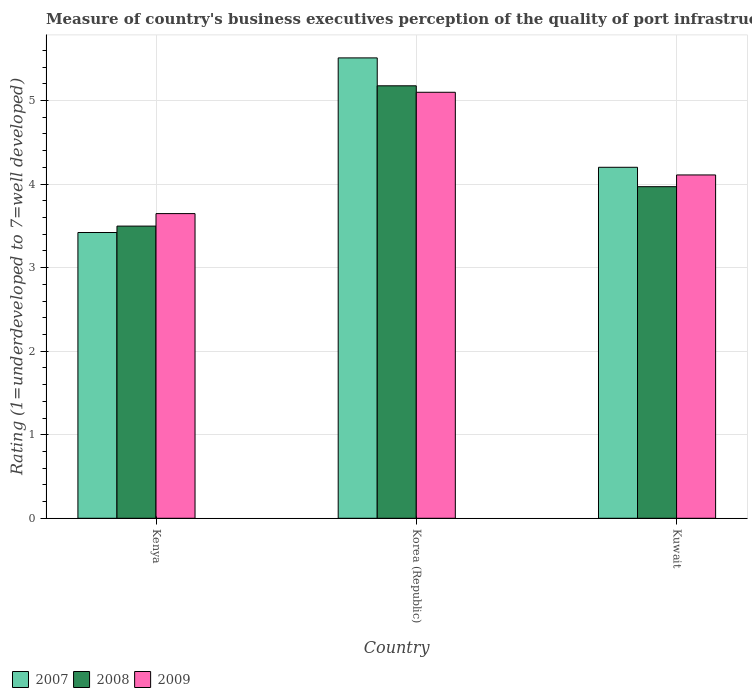How many groups of bars are there?
Offer a very short reply. 3. Are the number of bars per tick equal to the number of legend labels?
Ensure brevity in your answer.  Yes. How many bars are there on the 3rd tick from the left?
Give a very brief answer. 3. What is the label of the 1st group of bars from the left?
Provide a short and direct response. Kenya. In how many cases, is the number of bars for a given country not equal to the number of legend labels?
Your response must be concise. 0. What is the ratings of the quality of port infrastructure in 2008 in Kenya?
Give a very brief answer. 3.5. Across all countries, what is the maximum ratings of the quality of port infrastructure in 2008?
Your answer should be compact. 5.18. Across all countries, what is the minimum ratings of the quality of port infrastructure in 2007?
Make the answer very short. 3.42. In which country was the ratings of the quality of port infrastructure in 2007 maximum?
Offer a very short reply. Korea (Republic). In which country was the ratings of the quality of port infrastructure in 2007 minimum?
Give a very brief answer. Kenya. What is the total ratings of the quality of port infrastructure in 2009 in the graph?
Keep it short and to the point. 12.85. What is the difference between the ratings of the quality of port infrastructure in 2009 in Kenya and that in Korea (Republic)?
Keep it short and to the point. -1.45. What is the difference between the ratings of the quality of port infrastructure in 2007 in Korea (Republic) and the ratings of the quality of port infrastructure in 2009 in Kenya?
Provide a succinct answer. 1.86. What is the average ratings of the quality of port infrastructure in 2007 per country?
Offer a terse response. 4.38. What is the difference between the ratings of the quality of port infrastructure of/in 2009 and ratings of the quality of port infrastructure of/in 2007 in Korea (Republic)?
Your answer should be compact. -0.41. What is the ratio of the ratings of the quality of port infrastructure in 2007 in Kenya to that in Kuwait?
Your answer should be very brief. 0.81. Is the ratings of the quality of port infrastructure in 2009 in Korea (Republic) less than that in Kuwait?
Your answer should be very brief. No. Is the difference between the ratings of the quality of port infrastructure in 2009 in Korea (Republic) and Kuwait greater than the difference between the ratings of the quality of port infrastructure in 2007 in Korea (Republic) and Kuwait?
Ensure brevity in your answer.  No. What is the difference between the highest and the second highest ratings of the quality of port infrastructure in 2007?
Offer a terse response. -0.78. What is the difference between the highest and the lowest ratings of the quality of port infrastructure in 2008?
Offer a terse response. 1.68. In how many countries, is the ratings of the quality of port infrastructure in 2009 greater than the average ratings of the quality of port infrastructure in 2009 taken over all countries?
Your answer should be compact. 1. What does the 3rd bar from the left in Kenya represents?
Offer a very short reply. 2009. What does the 1st bar from the right in Kuwait represents?
Offer a very short reply. 2009. How many bars are there?
Make the answer very short. 9. Does the graph contain any zero values?
Your answer should be very brief. No. Does the graph contain grids?
Keep it short and to the point. Yes. Where does the legend appear in the graph?
Offer a very short reply. Bottom left. How many legend labels are there?
Offer a very short reply. 3. What is the title of the graph?
Provide a short and direct response. Measure of country's business executives perception of the quality of port infrastructure. Does "2008" appear as one of the legend labels in the graph?
Keep it short and to the point. Yes. What is the label or title of the Y-axis?
Your answer should be compact. Rating (1=underdeveloped to 7=well developed). What is the Rating (1=underdeveloped to 7=well developed) in 2007 in Kenya?
Provide a succinct answer. 3.42. What is the Rating (1=underdeveloped to 7=well developed) in 2008 in Kenya?
Offer a very short reply. 3.5. What is the Rating (1=underdeveloped to 7=well developed) of 2009 in Kenya?
Offer a very short reply. 3.65. What is the Rating (1=underdeveloped to 7=well developed) in 2007 in Korea (Republic)?
Make the answer very short. 5.51. What is the Rating (1=underdeveloped to 7=well developed) of 2008 in Korea (Republic)?
Provide a succinct answer. 5.18. What is the Rating (1=underdeveloped to 7=well developed) in 2009 in Korea (Republic)?
Offer a terse response. 5.1. What is the Rating (1=underdeveloped to 7=well developed) in 2007 in Kuwait?
Provide a succinct answer. 4.2. What is the Rating (1=underdeveloped to 7=well developed) of 2008 in Kuwait?
Your answer should be compact. 3.97. What is the Rating (1=underdeveloped to 7=well developed) in 2009 in Kuwait?
Your answer should be very brief. 4.11. Across all countries, what is the maximum Rating (1=underdeveloped to 7=well developed) in 2007?
Keep it short and to the point. 5.51. Across all countries, what is the maximum Rating (1=underdeveloped to 7=well developed) in 2008?
Ensure brevity in your answer.  5.18. Across all countries, what is the maximum Rating (1=underdeveloped to 7=well developed) of 2009?
Provide a short and direct response. 5.1. Across all countries, what is the minimum Rating (1=underdeveloped to 7=well developed) in 2007?
Make the answer very short. 3.42. Across all countries, what is the minimum Rating (1=underdeveloped to 7=well developed) in 2008?
Your answer should be very brief. 3.5. Across all countries, what is the minimum Rating (1=underdeveloped to 7=well developed) of 2009?
Provide a succinct answer. 3.65. What is the total Rating (1=underdeveloped to 7=well developed) in 2007 in the graph?
Ensure brevity in your answer.  13.13. What is the total Rating (1=underdeveloped to 7=well developed) in 2008 in the graph?
Ensure brevity in your answer.  12.64. What is the total Rating (1=underdeveloped to 7=well developed) in 2009 in the graph?
Ensure brevity in your answer.  12.85. What is the difference between the Rating (1=underdeveloped to 7=well developed) in 2007 in Kenya and that in Korea (Republic)?
Make the answer very short. -2.09. What is the difference between the Rating (1=underdeveloped to 7=well developed) of 2008 in Kenya and that in Korea (Republic)?
Provide a short and direct response. -1.68. What is the difference between the Rating (1=underdeveloped to 7=well developed) of 2009 in Kenya and that in Korea (Republic)?
Offer a very short reply. -1.45. What is the difference between the Rating (1=underdeveloped to 7=well developed) of 2007 in Kenya and that in Kuwait?
Keep it short and to the point. -0.78. What is the difference between the Rating (1=underdeveloped to 7=well developed) in 2008 in Kenya and that in Kuwait?
Give a very brief answer. -0.47. What is the difference between the Rating (1=underdeveloped to 7=well developed) of 2009 in Kenya and that in Kuwait?
Make the answer very short. -0.46. What is the difference between the Rating (1=underdeveloped to 7=well developed) of 2007 in Korea (Republic) and that in Kuwait?
Offer a very short reply. 1.31. What is the difference between the Rating (1=underdeveloped to 7=well developed) of 2008 in Korea (Republic) and that in Kuwait?
Offer a terse response. 1.21. What is the difference between the Rating (1=underdeveloped to 7=well developed) of 2007 in Kenya and the Rating (1=underdeveloped to 7=well developed) of 2008 in Korea (Republic)?
Keep it short and to the point. -1.76. What is the difference between the Rating (1=underdeveloped to 7=well developed) in 2007 in Kenya and the Rating (1=underdeveloped to 7=well developed) in 2009 in Korea (Republic)?
Keep it short and to the point. -1.68. What is the difference between the Rating (1=underdeveloped to 7=well developed) in 2008 in Kenya and the Rating (1=underdeveloped to 7=well developed) in 2009 in Korea (Republic)?
Offer a terse response. -1.6. What is the difference between the Rating (1=underdeveloped to 7=well developed) in 2007 in Kenya and the Rating (1=underdeveloped to 7=well developed) in 2008 in Kuwait?
Offer a terse response. -0.55. What is the difference between the Rating (1=underdeveloped to 7=well developed) of 2007 in Kenya and the Rating (1=underdeveloped to 7=well developed) of 2009 in Kuwait?
Make the answer very short. -0.69. What is the difference between the Rating (1=underdeveloped to 7=well developed) of 2008 in Kenya and the Rating (1=underdeveloped to 7=well developed) of 2009 in Kuwait?
Give a very brief answer. -0.61. What is the difference between the Rating (1=underdeveloped to 7=well developed) of 2007 in Korea (Republic) and the Rating (1=underdeveloped to 7=well developed) of 2008 in Kuwait?
Your answer should be very brief. 1.54. What is the difference between the Rating (1=underdeveloped to 7=well developed) in 2007 in Korea (Republic) and the Rating (1=underdeveloped to 7=well developed) in 2009 in Kuwait?
Your answer should be compact. 1.4. What is the difference between the Rating (1=underdeveloped to 7=well developed) of 2008 in Korea (Republic) and the Rating (1=underdeveloped to 7=well developed) of 2009 in Kuwait?
Offer a very short reply. 1.07. What is the average Rating (1=underdeveloped to 7=well developed) of 2007 per country?
Make the answer very short. 4.38. What is the average Rating (1=underdeveloped to 7=well developed) in 2008 per country?
Give a very brief answer. 4.21. What is the average Rating (1=underdeveloped to 7=well developed) in 2009 per country?
Offer a very short reply. 4.28. What is the difference between the Rating (1=underdeveloped to 7=well developed) in 2007 and Rating (1=underdeveloped to 7=well developed) in 2008 in Kenya?
Provide a short and direct response. -0.08. What is the difference between the Rating (1=underdeveloped to 7=well developed) of 2007 and Rating (1=underdeveloped to 7=well developed) of 2009 in Kenya?
Your answer should be compact. -0.23. What is the difference between the Rating (1=underdeveloped to 7=well developed) in 2008 and Rating (1=underdeveloped to 7=well developed) in 2009 in Kenya?
Offer a terse response. -0.15. What is the difference between the Rating (1=underdeveloped to 7=well developed) in 2007 and Rating (1=underdeveloped to 7=well developed) in 2008 in Korea (Republic)?
Provide a short and direct response. 0.33. What is the difference between the Rating (1=underdeveloped to 7=well developed) of 2007 and Rating (1=underdeveloped to 7=well developed) of 2009 in Korea (Republic)?
Give a very brief answer. 0.41. What is the difference between the Rating (1=underdeveloped to 7=well developed) in 2008 and Rating (1=underdeveloped to 7=well developed) in 2009 in Korea (Republic)?
Provide a short and direct response. 0.08. What is the difference between the Rating (1=underdeveloped to 7=well developed) of 2007 and Rating (1=underdeveloped to 7=well developed) of 2008 in Kuwait?
Your response must be concise. 0.23. What is the difference between the Rating (1=underdeveloped to 7=well developed) of 2007 and Rating (1=underdeveloped to 7=well developed) of 2009 in Kuwait?
Your response must be concise. 0.09. What is the difference between the Rating (1=underdeveloped to 7=well developed) in 2008 and Rating (1=underdeveloped to 7=well developed) in 2009 in Kuwait?
Give a very brief answer. -0.14. What is the ratio of the Rating (1=underdeveloped to 7=well developed) of 2007 in Kenya to that in Korea (Republic)?
Provide a short and direct response. 0.62. What is the ratio of the Rating (1=underdeveloped to 7=well developed) of 2008 in Kenya to that in Korea (Republic)?
Give a very brief answer. 0.68. What is the ratio of the Rating (1=underdeveloped to 7=well developed) in 2009 in Kenya to that in Korea (Republic)?
Give a very brief answer. 0.72. What is the ratio of the Rating (1=underdeveloped to 7=well developed) of 2007 in Kenya to that in Kuwait?
Your answer should be compact. 0.81. What is the ratio of the Rating (1=underdeveloped to 7=well developed) in 2008 in Kenya to that in Kuwait?
Give a very brief answer. 0.88. What is the ratio of the Rating (1=underdeveloped to 7=well developed) in 2009 in Kenya to that in Kuwait?
Make the answer very short. 0.89. What is the ratio of the Rating (1=underdeveloped to 7=well developed) in 2007 in Korea (Republic) to that in Kuwait?
Your response must be concise. 1.31. What is the ratio of the Rating (1=underdeveloped to 7=well developed) in 2008 in Korea (Republic) to that in Kuwait?
Ensure brevity in your answer.  1.3. What is the ratio of the Rating (1=underdeveloped to 7=well developed) of 2009 in Korea (Republic) to that in Kuwait?
Your response must be concise. 1.24. What is the difference between the highest and the second highest Rating (1=underdeveloped to 7=well developed) of 2007?
Make the answer very short. 1.31. What is the difference between the highest and the second highest Rating (1=underdeveloped to 7=well developed) of 2008?
Give a very brief answer. 1.21. What is the difference between the highest and the lowest Rating (1=underdeveloped to 7=well developed) in 2007?
Offer a terse response. 2.09. What is the difference between the highest and the lowest Rating (1=underdeveloped to 7=well developed) in 2008?
Your answer should be very brief. 1.68. What is the difference between the highest and the lowest Rating (1=underdeveloped to 7=well developed) of 2009?
Make the answer very short. 1.45. 